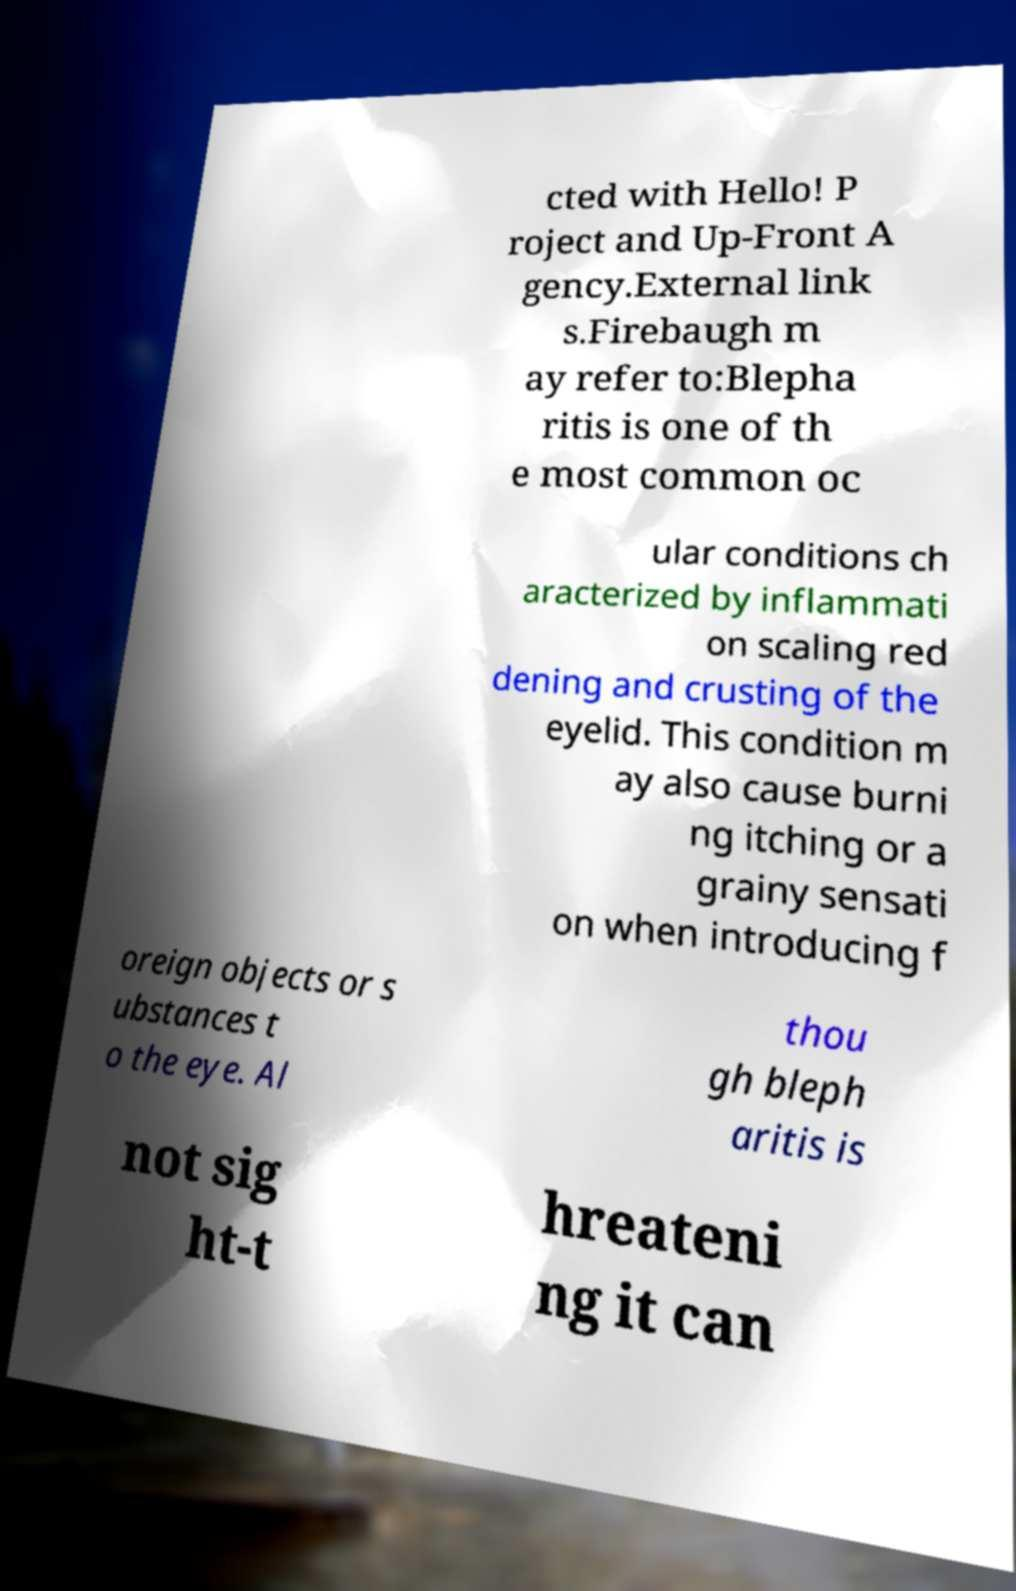Can you read and provide the text displayed in the image?This photo seems to have some interesting text. Can you extract and type it out for me? cted with Hello! P roject and Up-Front A gency.External link s.Firebaugh m ay refer to:Blepha ritis is one of th e most common oc ular conditions ch aracterized by inflammati on scaling red dening and crusting of the eyelid. This condition m ay also cause burni ng itching or a grainy sensati on when introducing f oreign objects or s ubstances t o the eye. Al thou gh bleph aritis is not sig ht-t hreateni ng it can 